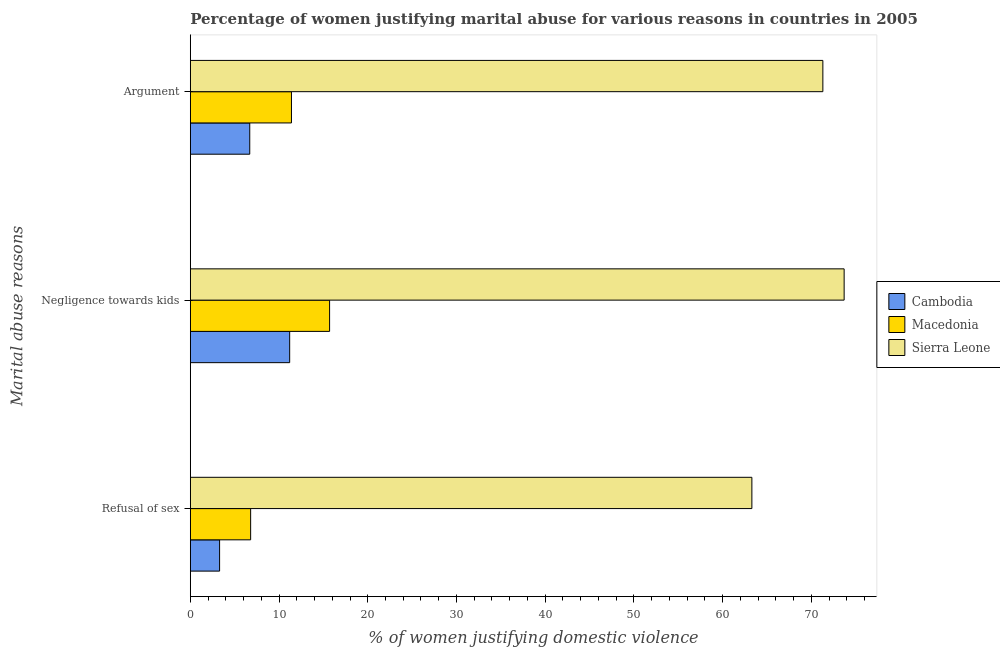Are the number of bars per tick equal to the number of legend labels?
Keep it short and to the point. Yes. How many bars are there on the 2nd tick from the bottom?
Keep it short and to the point. 3. What is the label of the 3rd group of bars from the top?
Your answer should be very brief. Refusal of sex. Across all countries, what is the maximum percentage of women justifying domestic violence due to refusal of sex?
Your answer should be compact. 63.3. Across all countries, what is the minimum percentage of women justifying domestic violence due to negligence towards kids?
Provide a short and direct response. 11.2. In which country was the percentage of women justifying domestic violence due to negligence towards kids maximum?
Your response must be concise. Sierra Leone. In which country was the percentage of women justifying domestic violence due to arguments minimum?
Keep it short and to the point. Cambodia. What is the total percentage of women justifying domestic violence due to arguments in the graph?
Make the answer very short. 89.4. What is the difference between the percentage of women justifying domestic violence due to refusal of sex in Sierra Leone and the percentage of women justifying domestic violence due to negligence towards kids in Cambodia?
Provide a succinct answer. 52.1. What is the average percentage of women justifying domestic violence due to refusal of sex per country?
Your response must be concise. 24.47. What is the difference between the percentage of women justifying domestic violence due to negligence towards kids and percentage of women justifying domestic violence due to refusal of sex in Sierra Leone?
Provide a succinct answer. 10.4. What is the ratio of the percentage of women justifying domestic violence due to refusal of sex in Cambodia to that in Sierra Leone?
Keep it short and to the point. 0.05. Is the percentage of women justifying domestic violence due to arguments in Macedonia less than that in Cambodia?
Give a very brief answer. No. In how many countries, is the percentage of women justifying domestic violence due to refusal of sex greater than the average percentage of women justifying domestic violence due to refusal of sex taken over all countries?
Your response must be concise. 1. What does the 2nd bar from the top in Argument represents?
Your response must be concise. Macedonia. What does the 2nd bar from the bottom in Refusal of sex represents?
Ensure brevity in your answer.  Macedonia. What is the difference between two consecutive major ticks on the X-axis?
Ensure brevity in your answer.  10. Does the graph contain any zero values?
Give a very brief answer. No. Does the graph contain grids?
Ensure brevity in your answer.  No. How many legend labels are there?
Provide a short and direct response. 3. How are the legend labels stacked?
Your response must be concise. Vertical. What is the title of the graph?
Offer a very short reply. Percentage of women justifying marital abuse for various reasons in countries in 2005. What is the label or title of the X-axis?
Provide a short and direct response. % of women justifying domestic violence. What is the label or title of the Y-axis?
Your answer should be very brief. Marital abuse reasons. What is the % of women justifying domestic violence of Sierra Leone in Refusal of sex?
Give a very brief answer. 63.3. What is the % of women justifying domestic violence in Cambodia in Negligence towards kids?
Ensure brevity in your answer.  11.2. What is the % of women justifying domestic violence of Sierra Leone in Negligence towards kids?
Ensure brevity in your answer.  73.7. What is the % of women justifying domestic violence of Cambodia in Argument?
Your response must be concise. 6.7. What is the % of women justifying domestic violence in Macedonia in Argument?
Make the answer very short. 11.4. What is the % of women justifying domestic violence in Sierra Leone in Argument?
Give a very brief answer. 71.3. Across all Marital abuse reasons, what is the maximum % of women justifying domestic violence of Sierra Leone?
Ensure brevity in your answer.  73.7. Across all Marital abuse reasons, what is the minimum % of women justifying domestic violence of Cambodia?
Give a very brief answer. 3.3. Across all Marital abuse reasons, what is the minimum % of women justifying domestic violence in Sierra Leone?
Provide a short and direct response. 63.3. What is the total % of women justifying domestic violence of Cambodia in the graph?
Your answer should be compact. 21.2. What is the total % of women justifying domestic violence of Macedonia in the graph?
Offer a terse response. 33.9. What is the total % of women justifying domestic violence of Sierra Leone in the graph?
Keep it short and to the point. 208.3. What is the difference between the % of women justifying domestic violence in Macedonia in Refusal of sex and that in Negligence towards kids?
Make the answer very short. -8.9. What is the difference between the % of women justifying domestic violence in Sierra Leone in Refusal of sex and that in Negligence towards kids?
Offer a terse response. -10.4. What is the difference between the % of women justifying domestic violence in Cambodia in Negligence towards kids and that in Argument?
Make the answer very short. 4.5. What is the difference between the % of women justifying domestic violence in Sierra Leone in Negligence towards kids and that in Argument?
Keep it short and to the point. 2.4. What is the difference between the % of women justifying domestic violence of Cambodia in Refusal of sex and the % of women justifying domestic violence of Sierra Leone in Negligence towards kids?
Your response must be concise. -70.4. What is the difference between the % of women justifying domestic violence in Macedonia in Refusal of sex and the % of women justifying domestic violence in Sierra Leone in Negligence towards kids?
Give a very brief answer. -66.9. What is the difference between the % of women justifying domestic violence in Cambodia in Refusal of sex and the % of women justifying domestic violence in Sierra Leone in Argument?
Provide a succinct answer. -68. What is the difference between the % of women justifying domestic violence of Macedonia in Refusal of sex and the % of women justifying domestic violence of Sierra Leone in Argument?
Your answer should be very brief. -64.5. What is the difference between the % of women justifying domestic violence of Cambodia in Negligence towards kids and the % of women justifying domestic violence of Sierra Leone in Argument?
Give a very brief answer. -60.1. What is the difference between the % of women justifying domestic violence in Macedonia in Negligence towards kids and the % of women justifying domestic violence in Sierra Leone in Argument?
Give a very brief answer. -55.6. What is the average % of women justifying domestic violence in Cambodia per Marital abuse reasons?
Your answer should be very brief. 7.07. What is the average % of women justifying domestic violence in Sierra Leone per Marital abuse reasons?
Provide a succinct answer. 69.43. What is the difference between the % of women justifying domestic violence in Cambodia and % of women justifying domestic violence in Sierra Leone in Refusal of sex?
Make the answer very short. -60. What is the difference between the % of women justifying domestic violence in Macedonia and % of women justifying domestic violence in Sierra Leone in Refusal of sex?
Offer a very short reply. -56.5. What is the difference between the % of women justifying domestic violence of Cambodia and % of women justifying domestic violence of Sierra Leone in Negligence towards kids?
Offer a terse response. -62.5. What is the difference between the % of women justifying domestic violence in Macedonia and % of women justifying domestic violence in Sierra Leone in Negligence towards kids?
Your answer should be very brief. -58. What is the difference between the % of women justifying domestic violence of Cambodia and % of women justifying domestic violence of Sierra Leone in Argument?
Your answer should be very brief. -64.6. What is the difference between the % of women justifying domestic violence in Macedonia and % of women justifying domestic violence in Sierra Leone in Argument?
Offer a very short reply. -59.9. What is the ratio of the % of women justifying domestic violence of Cambodia in Refusal of sex to that in Negligence towards kids?
Your response must be concise. 0.29. What is the ratio of the % of women justifying domestic violence in Macedonia in Refusal of sex to that in Negligence towards kids?
Your answer should be compact. 0.43. What is the ratio of the % of women justifying domestic violence in Sierra Leone in Refusal of sex to that in Negligence towards kids?
Your response must be concise. 0.86. What is the ratio of the % of women justifying domestic violence in Cambodia in Refusal of sex to that in Argument?
Ensure brevity in your answer.  0.49. What is the ratio of the % of women justifying domestic violence of Macedonia in Refusal of sex to that in Argument?
Provide a succinct answer. 0.6. What is the ratio of the % of women justifying domestic violence in Sierra Leone in Refusal of sex to that in Argument?
Ensure brevity in your answer.  0.89. What is the ratio of the % of women justifying domestic violence of Cambodia in Negligence towards kids to that in Argument?
Your answer should be very brief. 1.67. What is the ratio of the % of women justifying domestic violence in Macedonia in Negligence towards kids to that in Argument?
Offer a very short reply. 1.38. What is the ratio of the % of women justifying domestic violence of Sierra Leone in Negligence towards kids to that in Argument?
Keep it short and to the point. 1.03. What is the difference between the highest and the second highest % of women justifying domestic violence of Cambodia?
Make the answer very short. 4.5. What is the difference between the highest and the lowest % of women justifying domestic violence in Cambodia?
Your answer should be very brief. 7.9. 